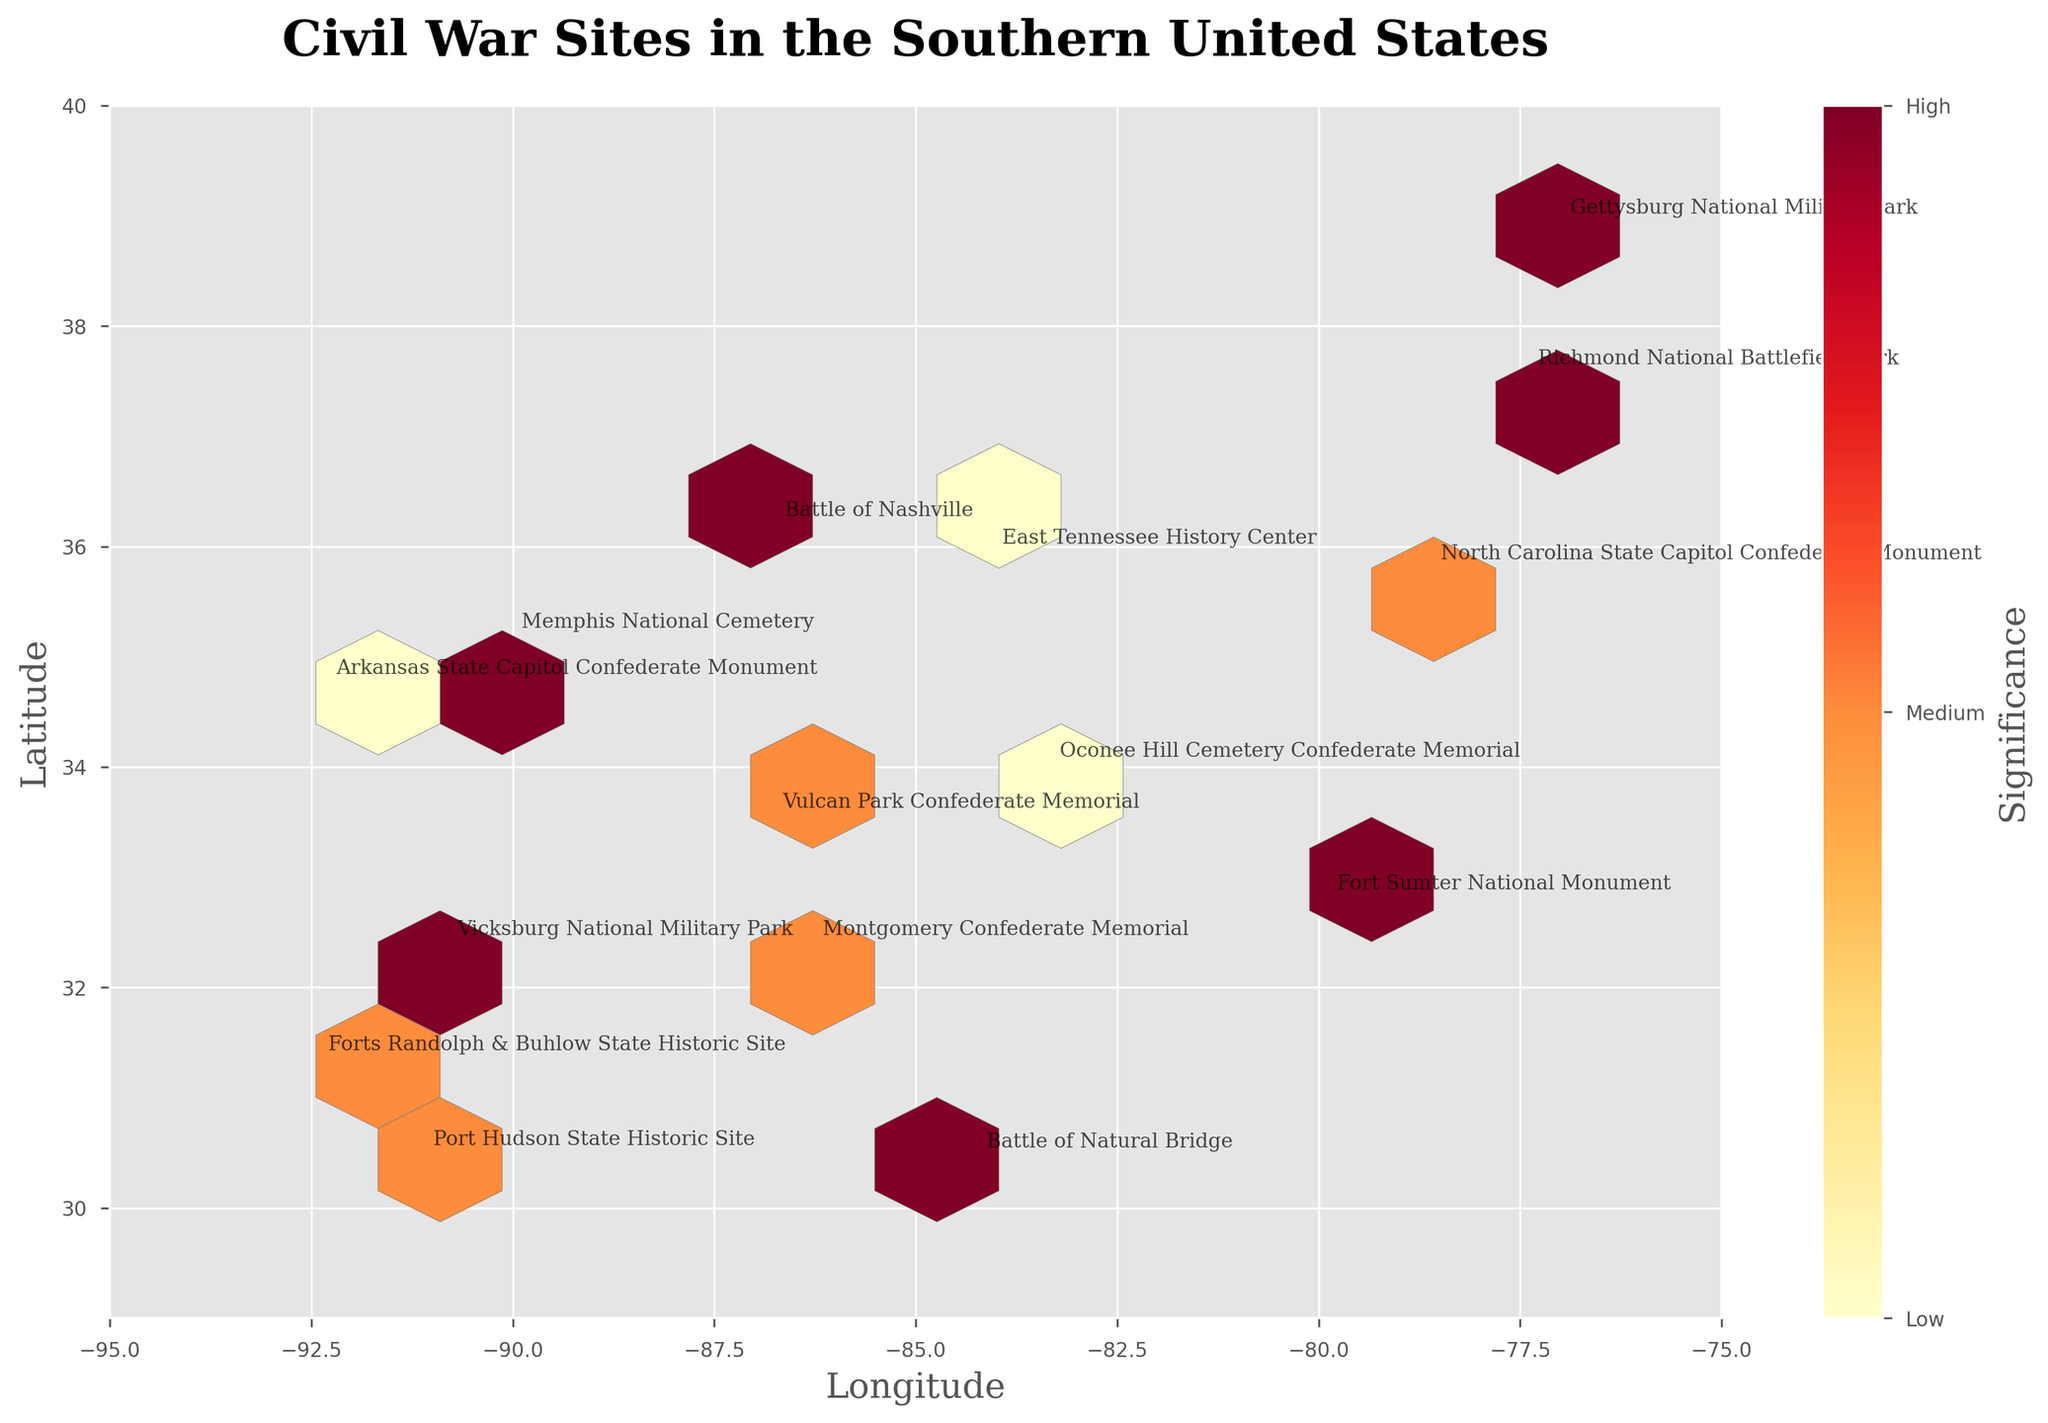What is the title of the figure? The title is present at the top of the figure in boldfaced text. It reads "Civil War Sites in the Southern United States."
Answer: Civil War Sites in the Southern United States What variable is mapped to the color in the hexbin plot? The color bar to the right of the plot (shaded from light yellow to deep red) shows the significance level, with labels for 'Low,' 'Medium,' and 'High.'
Answer: Significance Which significance level has the highest density of sites? The color bar indicates that darker red shades represent higher significance. By observing the plot, we see that the regions with the most sites are marked in darker shades of red, indicating a 'High' significance level.
Answer: High How many unique Confederate Monuments can be found on this plot? By looking at the map and checking the colored markers associated with the "Monument" type, we can count the unique annotations pointing to these monuments. Based on the annotation labels, there are 7 unique Confederate Monuments visible.
Answer: 7 Which site is located at the extreme eastern longitude in the plot? To find the easternmost site, we examine the far right of the plot along the x-axis (Longitude). The site labeled "Fort Sumter National Monument" is located at the easternmost point, around -79.9309 longitude.
Answer: Fort Sumter National Monument Is the site "Memphis National Cemetery" marked as having high significance? By identifying the label "Memphis National Cemetery" in the hexbin, we observe the color density at its location. This site is within a darker red bin, which corresponds to high significance.
Answer: Yes Which city has the closest concentration of Civil War sites marked as high significance around the central southern region? By checking the hexagonal bins and their coloring, high significance areas are centered around darker red bins. The central southern region falls around Alabama and Mississippi, particularly near Montgomery and Vicksburg. Upon further inspection, Vicksburg has a notable density of high significance sites.
Answer: Vicksburg What are the latitude and longitude bounds of the data plot? The figure's axes show the bounds. The latitude y-axis ranges from about 29 to 40, while the longitude x-axis ranges from about -95 to -75.
Answer: Latitude: [29, 40], Longitude: [-95, -75] How many sites have a significance level of 'Medium'? By examining the color gradients (orange representing medium significance) at multiple locations and counting the associated annotations, there are about 5 sites with 'Medium' significance.
Answer: 5 Which site has the exact latitude of 31.3183? The label for the site is directly annotated at the specified latitude, which is "Forts Randolph & Buhlow State Historic Site" according to the figure.
Answer: Forts Randolph & Buhlow State Historic Site 